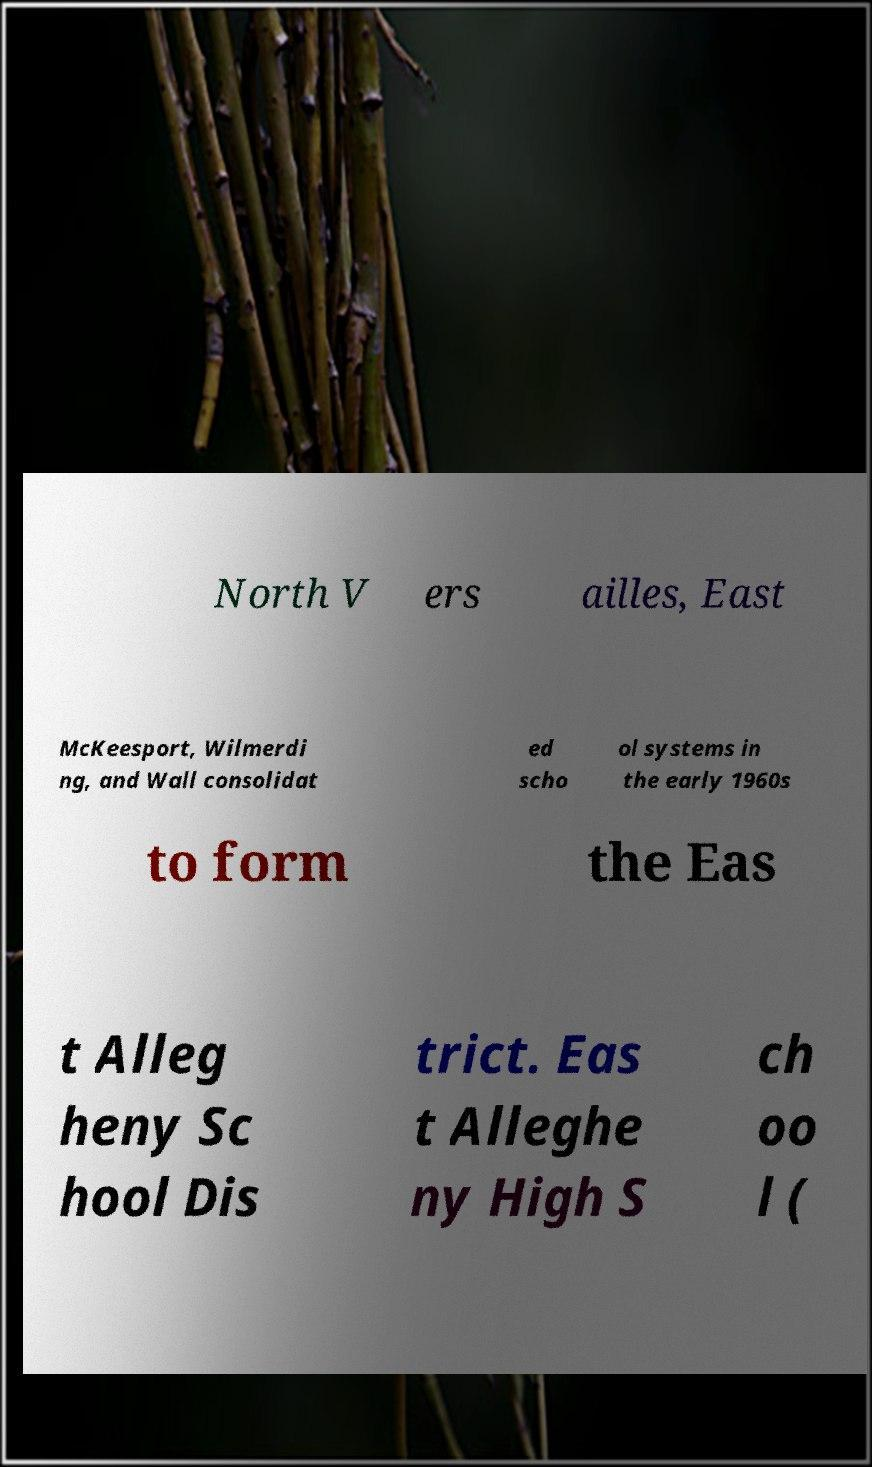Can you accurately transcribe the text from the provided image for me? North V ers ailles, East McKeesport, Wilmerdi ng, and Wall consolidat ed scho ol systems in the early 1960s to form the Eas t Alleg heny Sc hool Dis trict. Eas t Alleghe ny High S ch oo l ( 